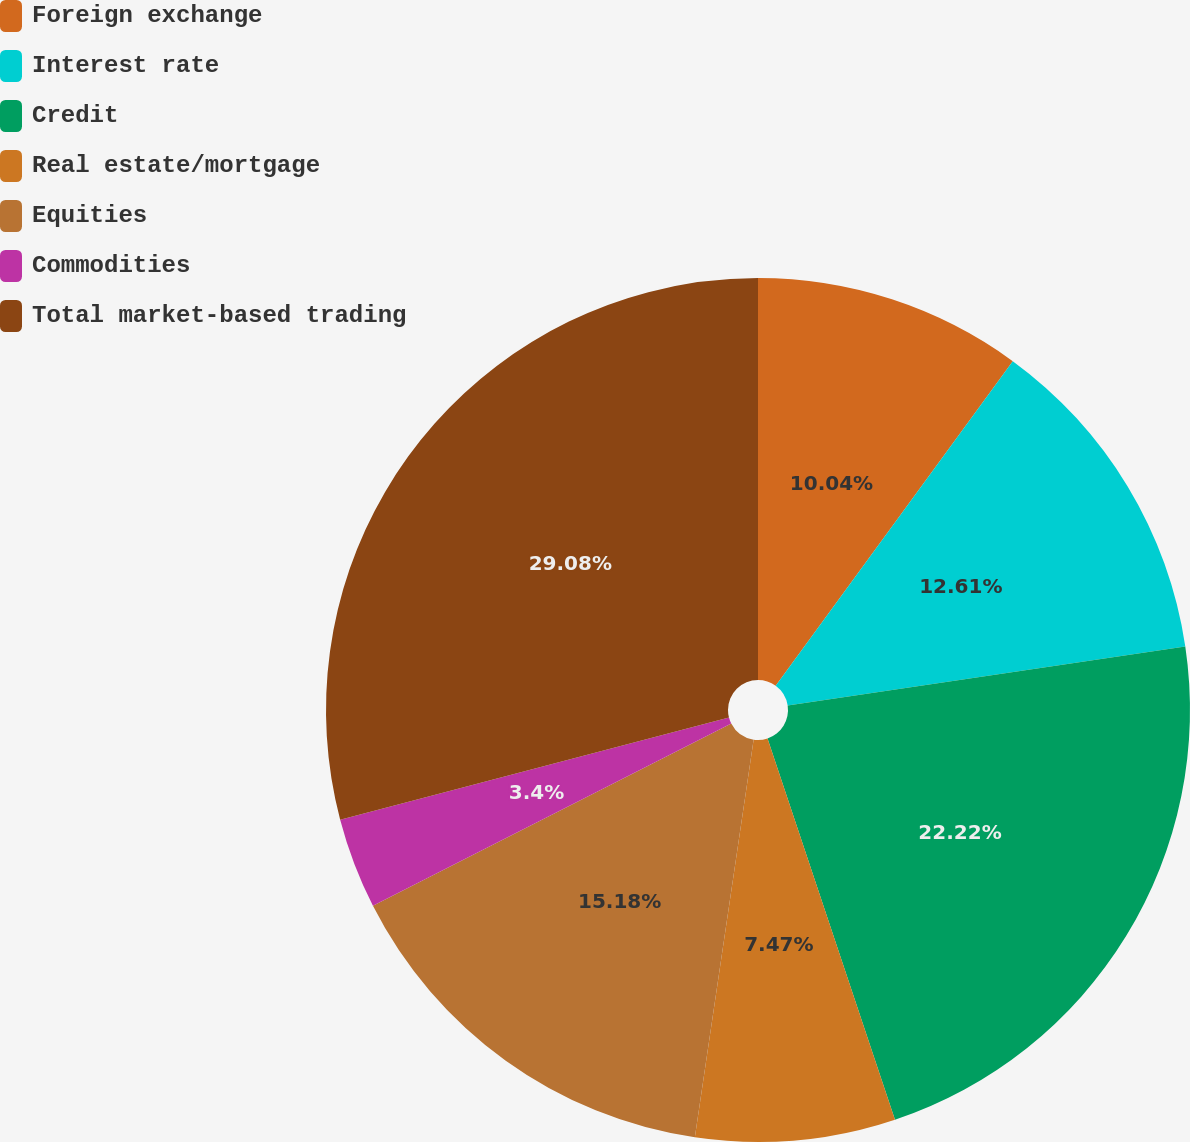Convert chart. <chart><loc_0><loc_0><loc_500><loc_500><pie_chart><fcel>Foreign exchange<fcel>Interest rate<fcel>Credit<fcel>Real estate/mortgage<fcel>Equities<fcel>Commodities<fcel>Total market-based trading<nl><fcel>10.04%<fcel>12.61%<fcel>22.22%<fcel>7.47%<fcel>15.18%<fcel>3.4%<fcel>29.09%<nl></chart> 